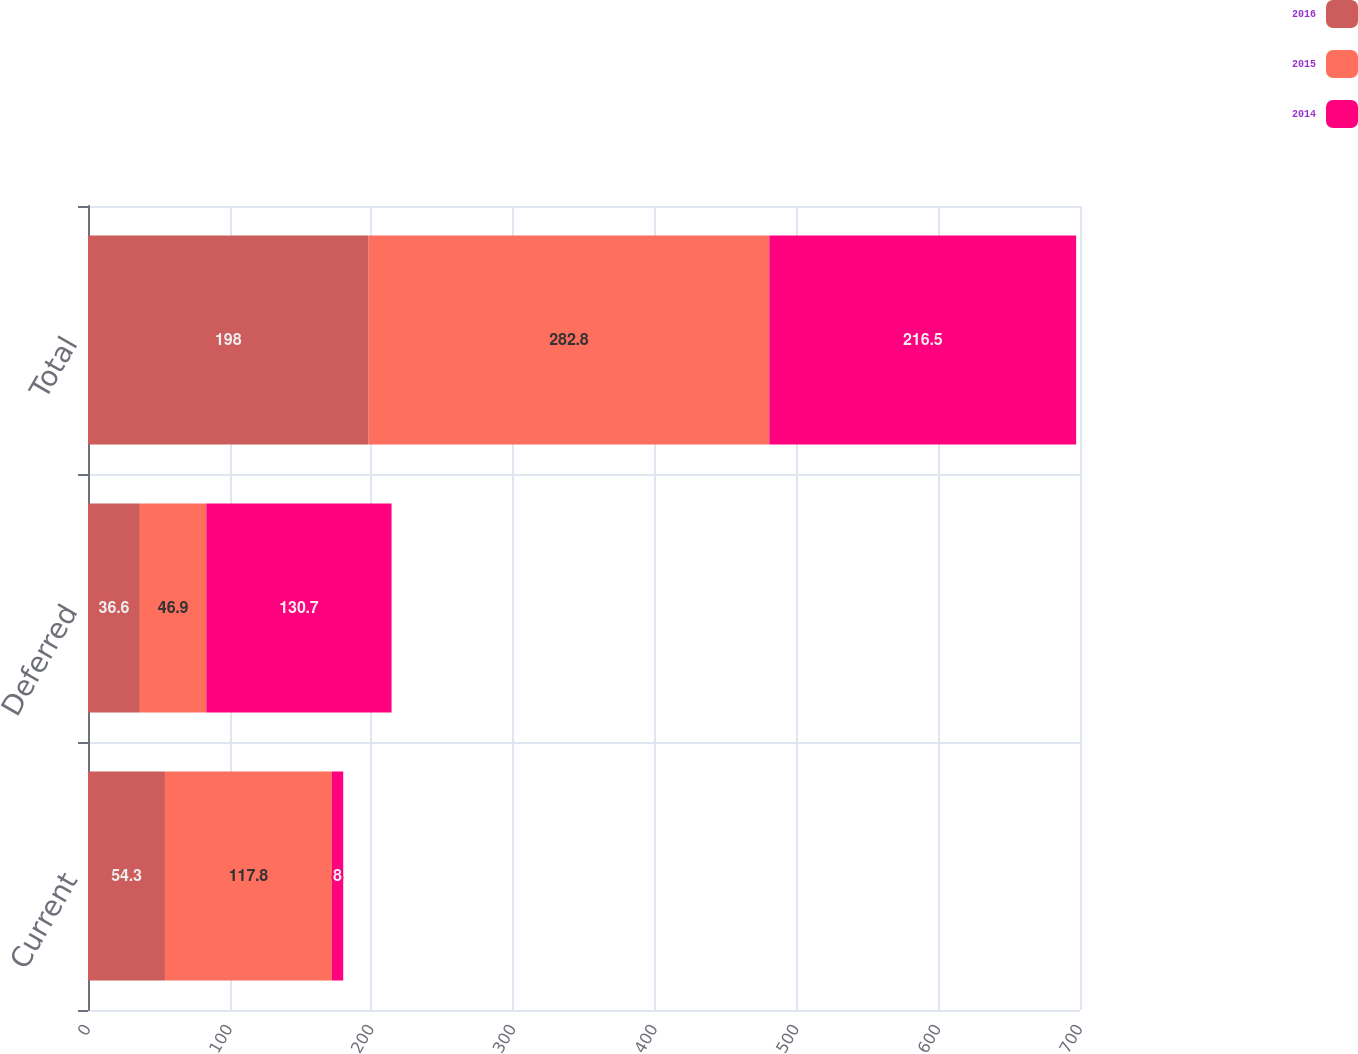Convert chart to OTSL. <chart><loc_0><loc_0><loc_500><loc_500><stacked_bar_chart><ecel><fcel>Current<fcel>Deferred<fcel>Total<nl><fcel>2016<fcel>54.3<fcel>36.6<fcel>198<nl><fcel>2015<fcel>117.8<fcel>46.9<fcel>282.8<nl><fcel>2014<fcel>8<fcel>130.7<fcel>216.5<nl></chart> 